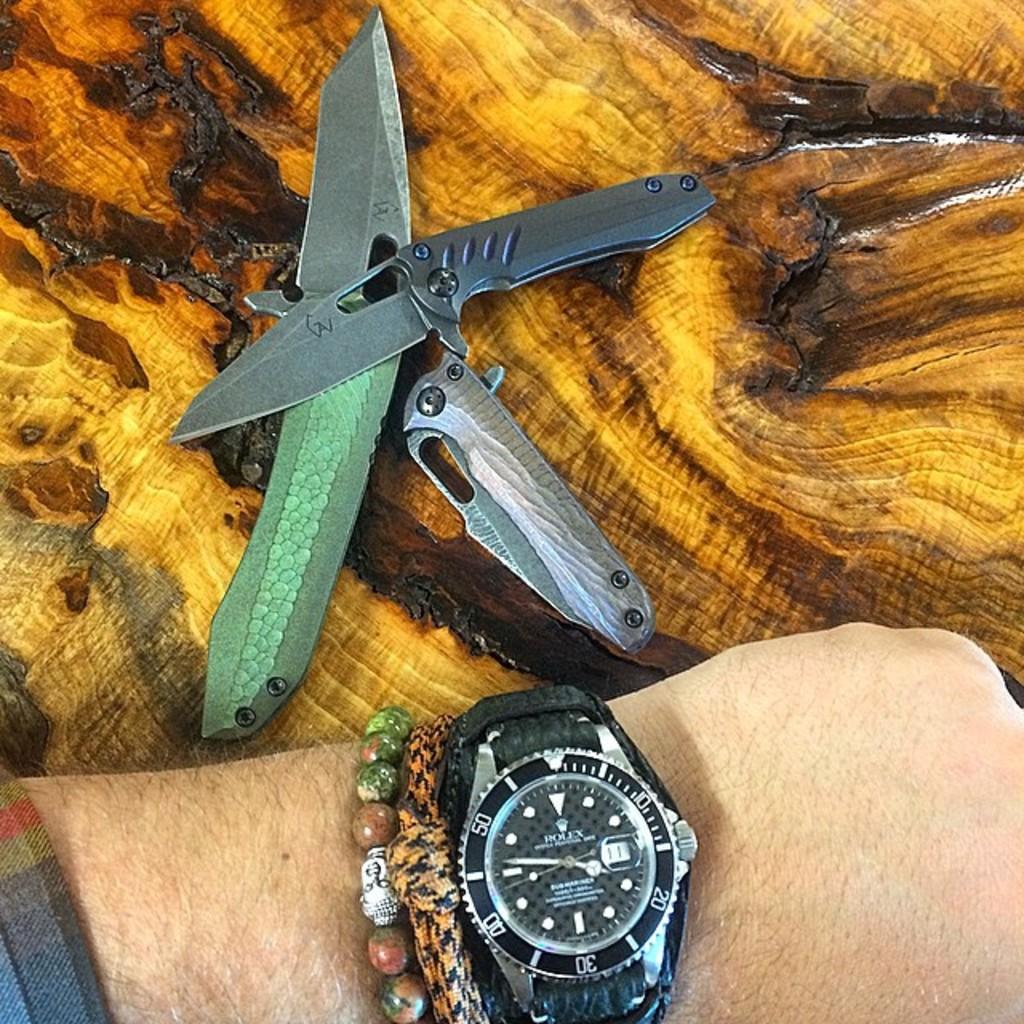What brand is the watch?
Provide a short and direct response. Rolex. What time is on the watch?
Your answer should be compact. 3:47. 